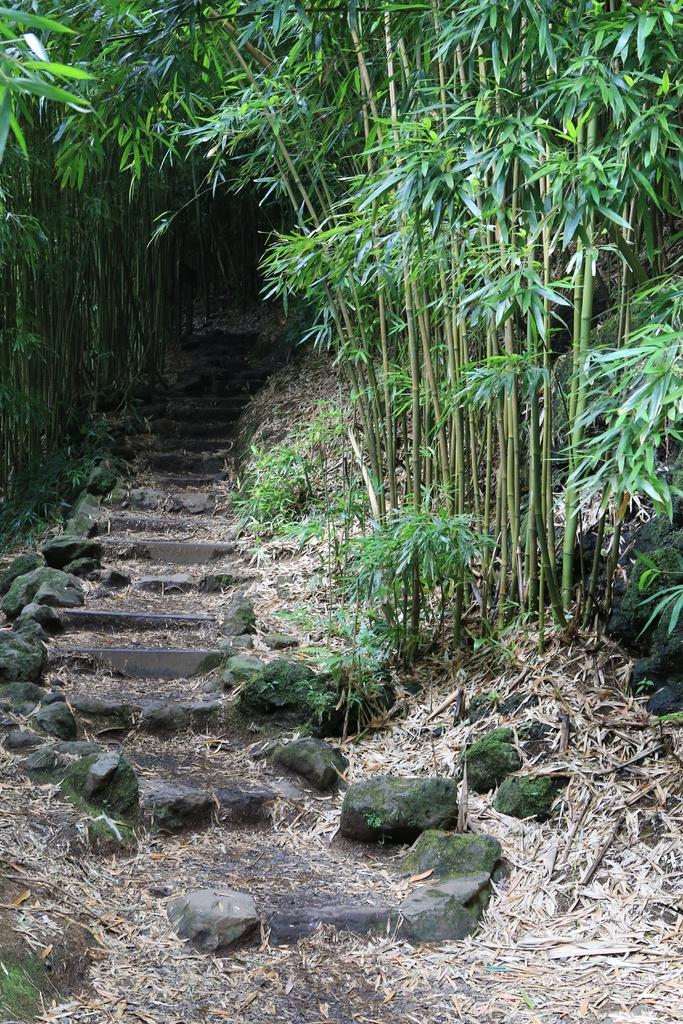What can be seen in the image that people use to move between different levels? There are stairs in the image. What is present alongside the stairs in the image? There are plants on both sides of the stairs. What type of vase can be seen smashing into the plants on the stairs in the image? There is no vase present in the image, and therefore no such activity can be observed. What type of flowers are growing on the plants alongside the stairs in the image? The provided facts do not mention any flowers; only the presence of plants is mentioned. 